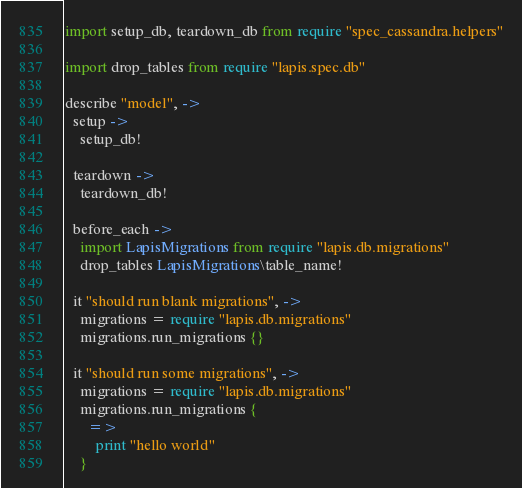Convert code to text. <code><loc_0><loc_0><loc_500><loc_500><_MoonScript_>import setup_db, teardown_db from require "spec_cassandra.helpers"

import drop_tables from require "lapis.spec.db"

describe "model", ->
  setup ->
    setup_db!

  teardown ->
    teardown_db!

  before_each ->
    import LapisMigrations from require "lapis.db.migrations"
    drop_tables LapisMigrations\table_name!

  it "should run blank migrations", ->
    migrations = require "lapis.db.migrations"
    migrations.run_migrations {}

  it "should run some migrations", ->
    migrations = require "lapis.db.migrations"
    migrations.run_migrations {
      =>
        print "hello world"
    }

</code> 